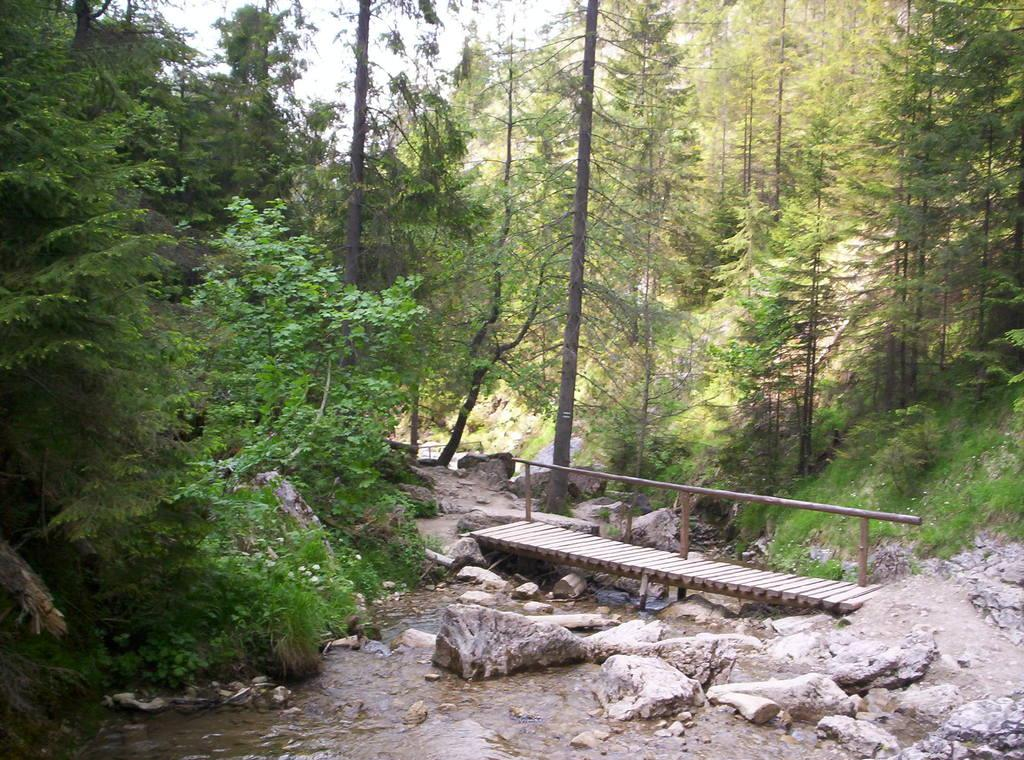What type of natural elements can be seen in the image? There are trees and plants in the image. What other objects can be seen in the image? There are rocks and a bridge in the image. Can you describe the bridge in the image? The bridge is over water in the image. What part of the natural environment is visible in the image? The sky is visible in the image. What color is the pencil used to draw the hair in the image? There is no pencil or hair present in the image; it features natural elements like trees, plants, rocks, and a bridge over water. 